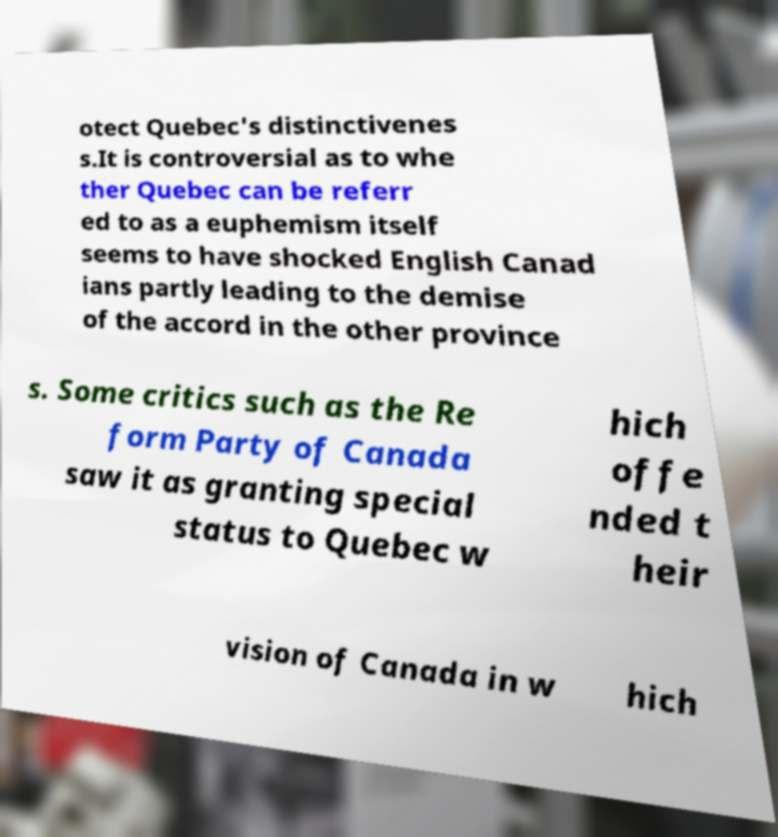There's text embedded in this image that I need extracted. Can you transcribe it verbatim? otect Quebec's distinctivenes s.It is controversial as to whe ther Quebec can be referr ed to as a euphemism itself seems to have shocked English Canad ians partly leading to the demise of the accord in the other province s. Some critics such as the Re form Party of Canada saw it as granting special status to Quebec w hich offe nded t heir vision of Canada in w hich 